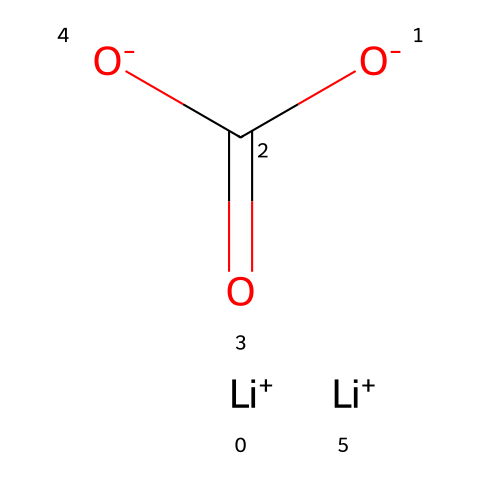what is the cation present in this chemical structure? The chemical has lithium ions represented by [Li+], indicating that lithium is the cation present in the structure.
Answer: lithium how many anionic components are evident in this chemical? The structure includes two carboxylate groups, which are represented as [O-]C(=O)[O-]. Therefore, there are two anionic components confirmed by their presence.
Answer: two what functional group does the anionic part of this chemical belong to? The anionic part, which is [O-]C(=O)[O-], refers to a carboxylate functional group, commonly recognized in organic chemistry.
Answer: carboxylate how many lithium ions are present in this chemical? There are two instances in the chemical structure where lithium ions [Li+] are indicated, showing that two lithium ions are present in total.
Answer: two what type of compound is formed by the combination of lithium and the anionic groups? This combination typically forms a lithium salt, which is a type of electrolyte used in mood-stabilizing medications.
Answer: lithium salt which property of this compound contributes to its classification as an electrolyte? The presence of freely moving ions, specifically lithium and the anionic components, allows it to conduct electricity when dissolved in water or melted.
Answer: ionic conductivity 